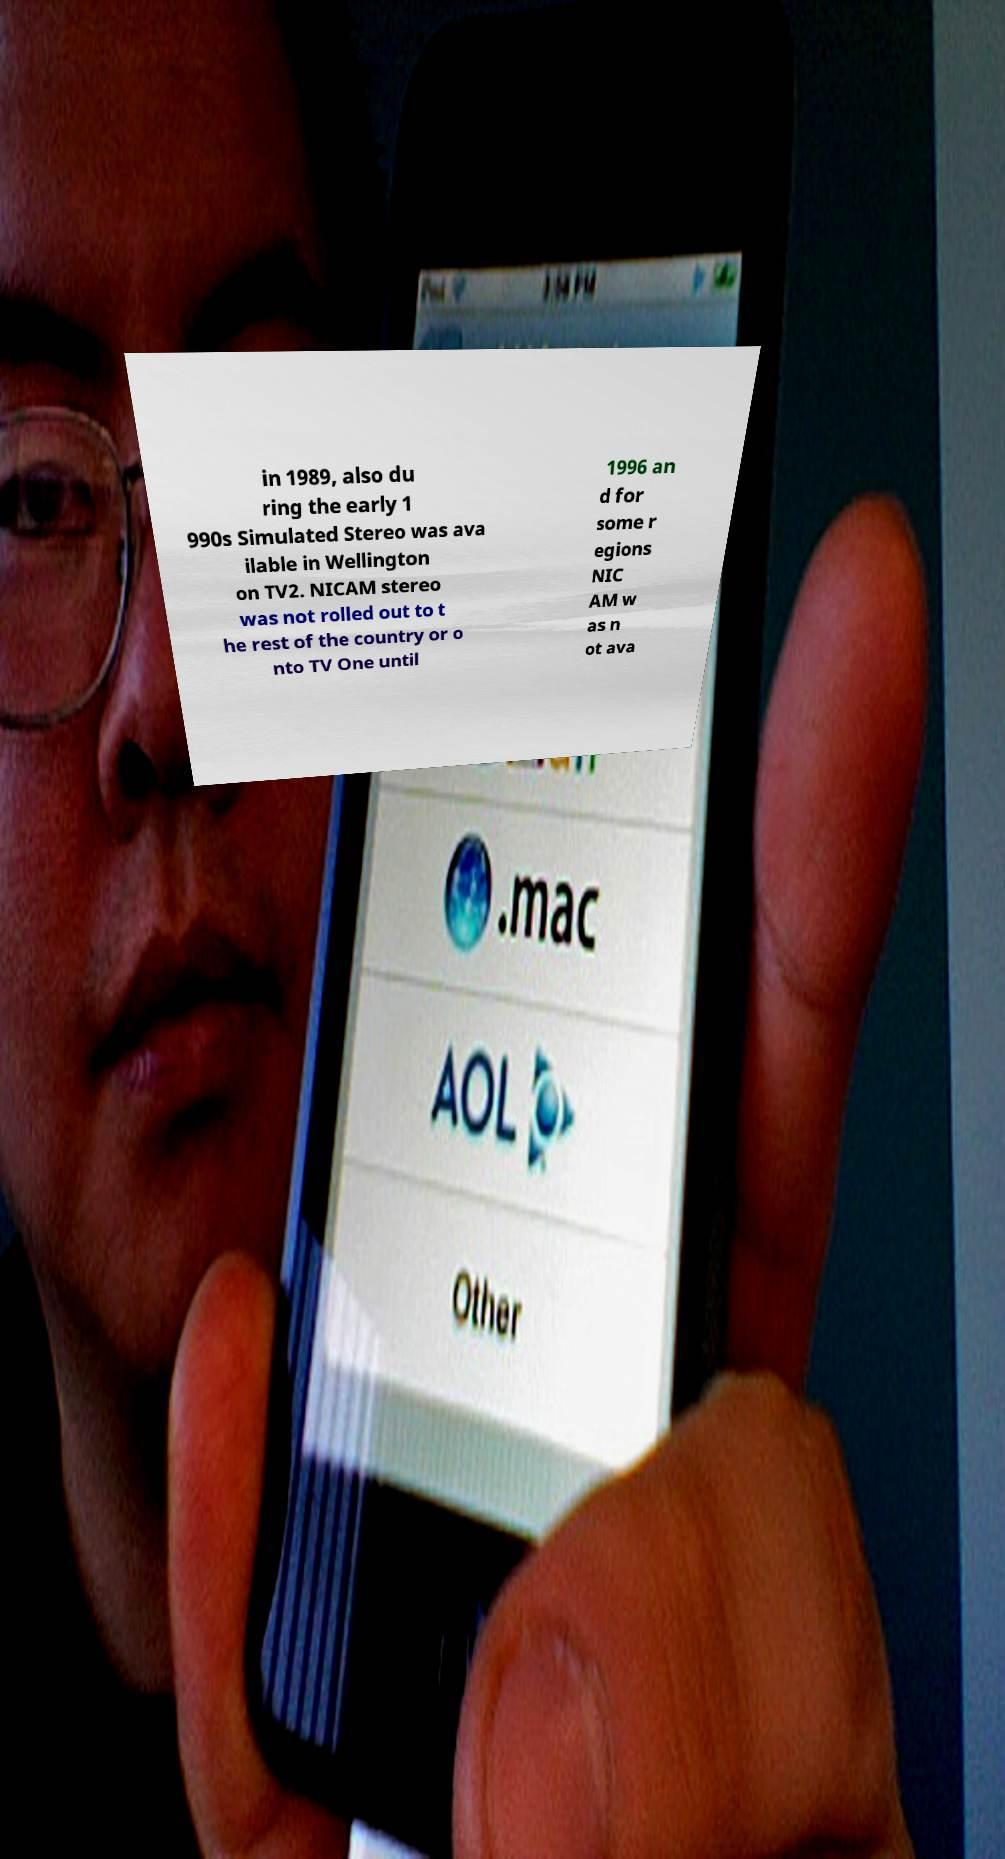There's text embedded in this image that I need extracted. Can you transcribe it verbatim? in 1989, also du ring the early 1 990s Simulated Stereo was ava ilable in Wellington on TV2. NICAM stereo was not rolled out to t he rest of the country or o nto TV One until 1996 an d for some r egions NIC AM w as n ot ava 